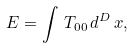<formula> <loc_0><loc_0><loc_500><loc_500>\, E = \int \, T _ { 0 0 } \, d ^ { D } \, x ,</formula> 